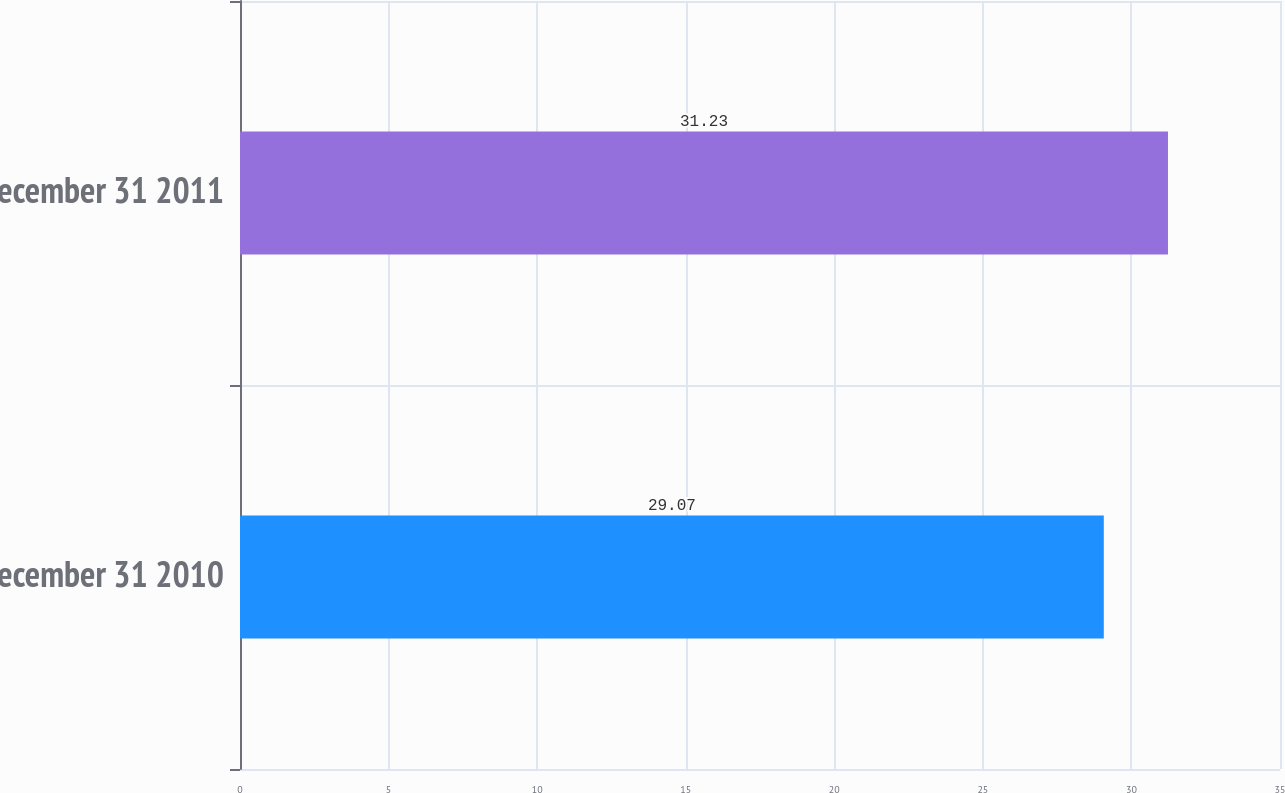Convert chart to OTSL. <chart><loc_0><loc_0><loc_500><loc_500><bar_chart><fcel>December 31 2010<fcel>December 31 2011<nl><fcel>29.07<fcel>31.23<nl></chart> 